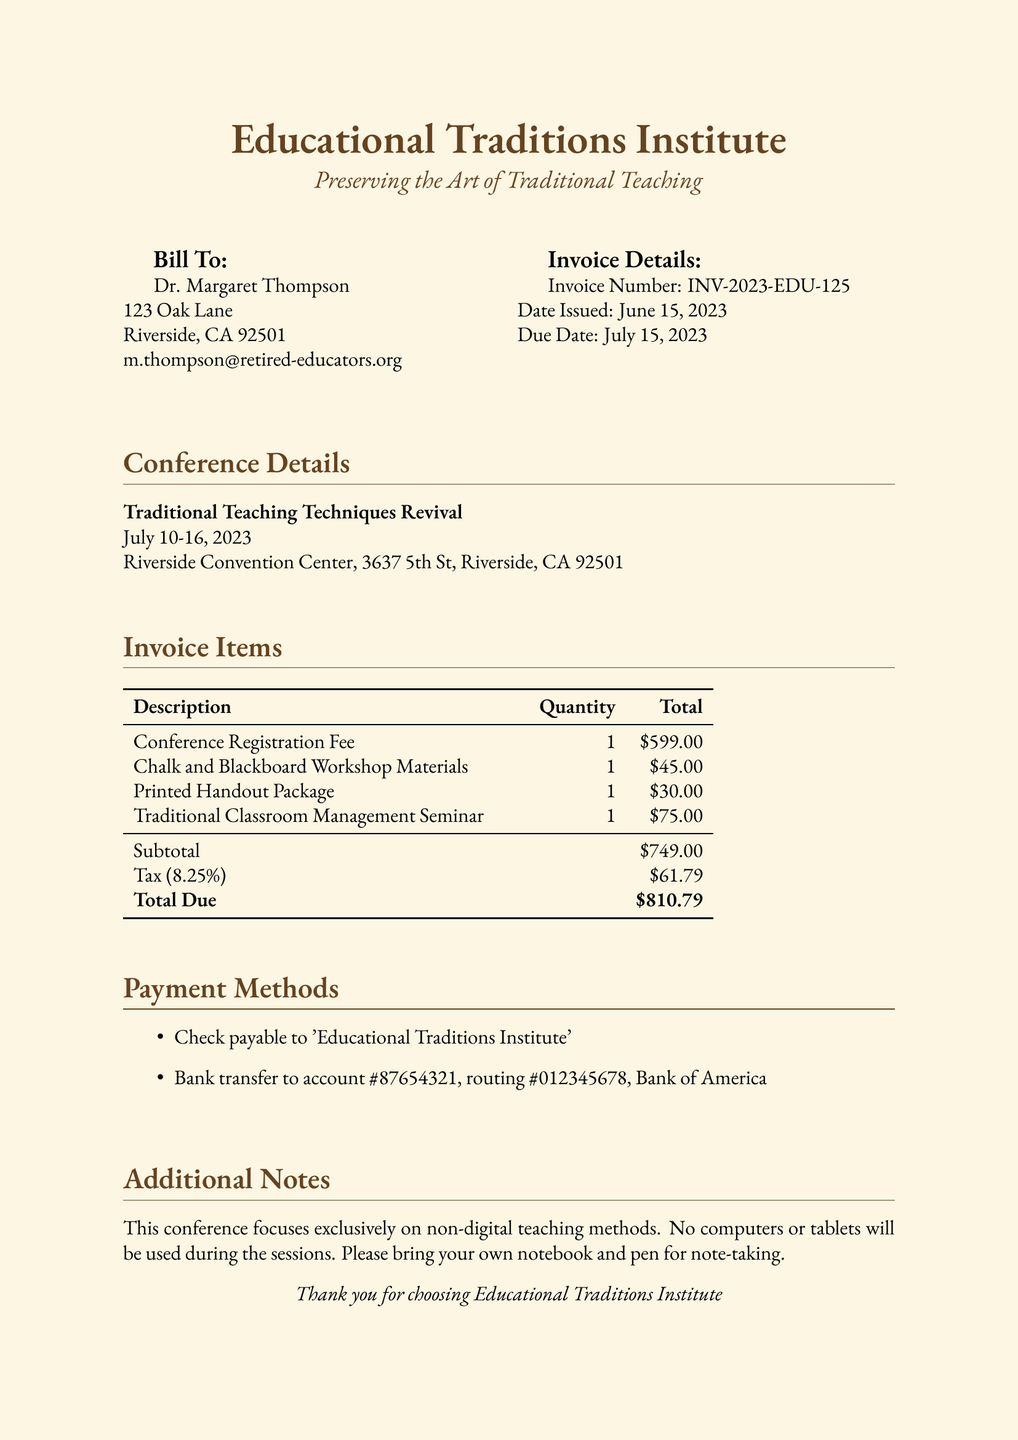What is the invoice number? The invoice number is a unique identifier for the bill and can be found in the invoice details section.
Answer: INV-2023-EDU-125 What is the total amount due? The total amount due is calculated by adding the subtotal and tax together, as stated at the bottom of the invoice items.
Answer: $810.79 What are the dates of the conference? The dates of the conference are specified clearly in the conference details section of the document.
Answer: July 10-16, 2023 Who is the invoice billed to? The name of the person the invoice is billed to is mentioned at the top under the "Bill To" section.
Answer: Dr. Margaret Thompson What payment methods are accepted? The document lists the ways in which payment can be made, which is a specific detail for this type of document.
Answer: Check and Bank transfer How much is the tax amount? The tax amount is specified in the invoice items section, providing detailed financial information.
Answer: $61.79 What is the subtotal before tax? The subtotal represents the total before tax and is clearly indicated in the invoice items table.
Answer: $749.00 What type of teaching methods does the conference focus on? The conference's focus is clearly stated in the additional notes section of the document.
Answer: Non-digital teaching methods How many items are listed on the invoice? The number of invoice items is indicated within the invoice items section by counting the entries.
Answer: 4 